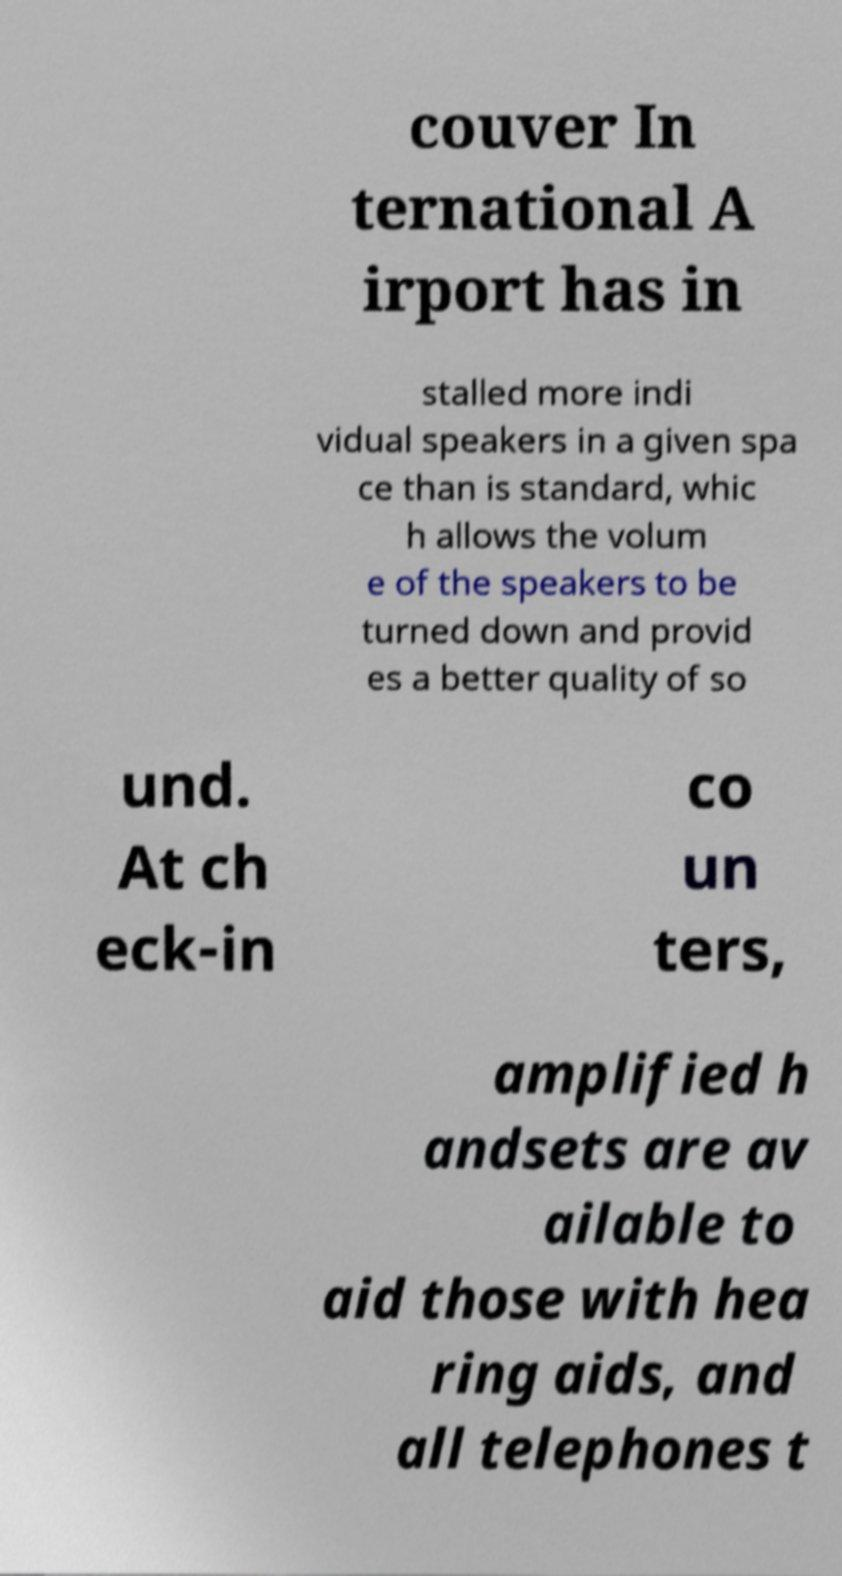Please read and relay the text visible in this image. What does it say? couver In ternational A irport has in stalled more indi vidual speakers in a given spa ce than is standard, whic h allows the volum e of the speakers to be turned down and provid es a better quality of so und. At ch eck-in co un ters, amplified h andsets are av ailable to aid those with hea ring aids, and all telephones t 